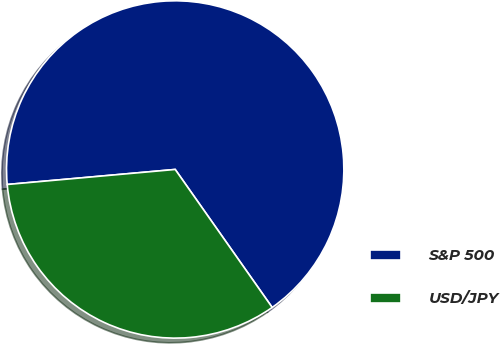<chart> <loc_0><loc_0><loc_500><loc_500><pie_chart><fcel>S&P 500<fcel>USD/JPY<nl><fcel>66.67%<fcel>33.33%<nl></chart> 